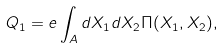<formula> <loc_0><loc_0><loc_500><loc_500>Q _ { 1 } = e \int _ { A } d X _ { 1 } d X _ { 2 } \Pi ( X _ { 1 } , X _ { 2 } ) ,</formula> 